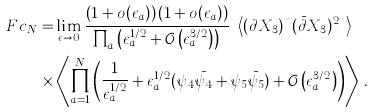Convert formula to latex. <formula><loc_0><loc_0><loc_500><loc_500>\ F c _ { N } = & \lim _ { \epsilon \to 0 } \frac { \left ( 1 + o ( \epsilon _ { a } ) \right ) \left ( 1 + o ( \epsilon _ { a } ) \right ) } { \prod _ { a } \left ( \epsilon _ { a } ^ { 1 / 2 } + \mathcal { O } \left ( \epsilon _ { a } ^ { 3 / 2 } \right ) \right ) } \ \left \langle ( \partial X _ { 3 } ) ^ { n } ( \bar { \partial } X _ { 3 } ) ^ { 2 n } \right \rangle \\ \times & \left \langle \prod _ { a = 1 } ^ { N } \left ( \frac { 1 } { \epsilon _ { a } ^ { 1 / 2 } } + \epsilon _ { a } ^ { 1 / 2 } ( \psi _ { 4 } \bar { \psi _ { 4 } } + \psi _ { 5 } \bar { \psi _ { 5 } } ) + \mathcal { O } \left ( \epsilon _ { a } ^ { 3 / 2 } \right ) \right ) \right \rangle \, .</formula> 